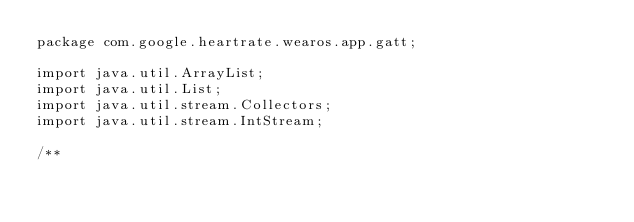Convert code to text. <code><loc_0><loc_0><loc_500><loc_500><_Java_>package com.google.heartrate.wearos.app.gatt;

import java.util.ArrayList;
import java.util.List;
import java.util.stream.Collectors;
import java.util.stream.IntStream;

/**</code> 